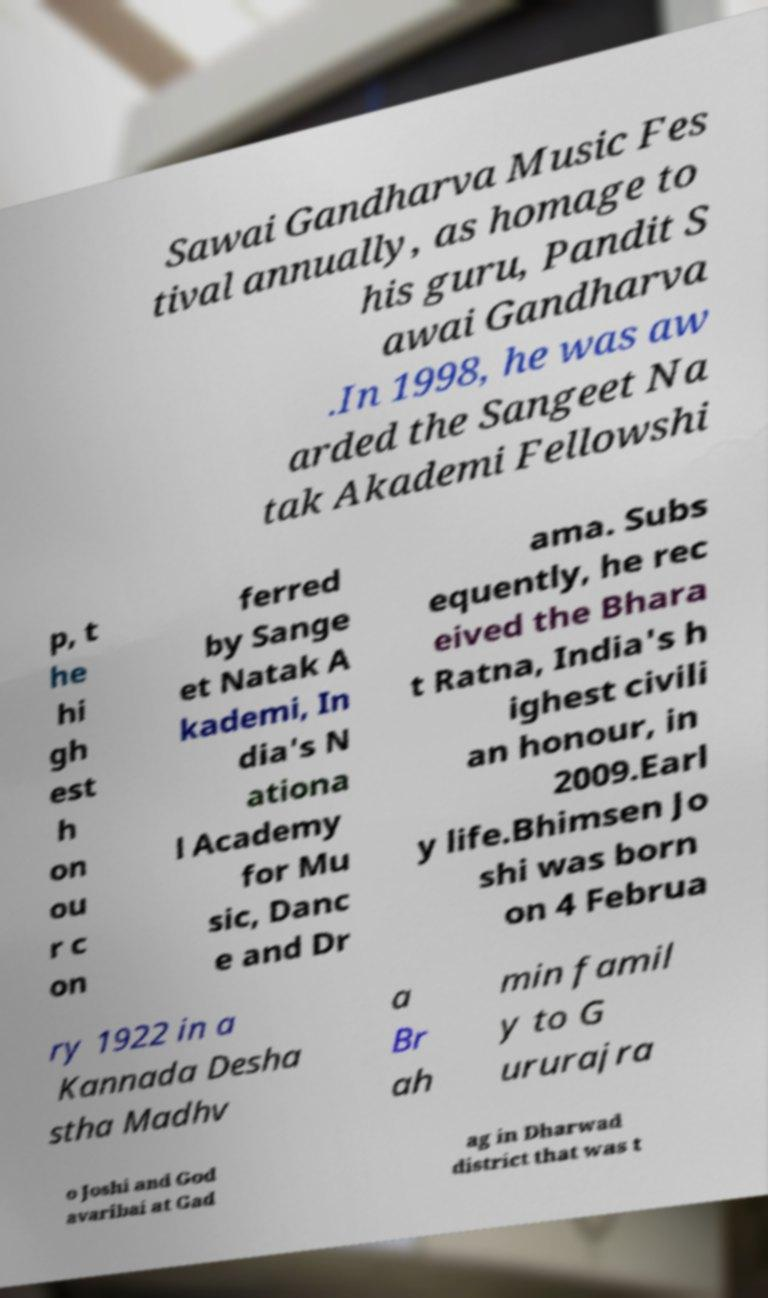I need the written content from this picture converted into text. Can you do that? Sawai Gandharva Music Fes tival annually, as homage to his guru, Pandit S awai Gandharva .In 1998, he was aw arded the Sangeet Na tak Akademi Fellowshi p, t he hi gh est h on ou r c on ferred by Sange et Natak A kademi, In dia's N ationa l Academy for Mu sic, Danc e and Dr ama. Subs equently, he rec eived the Bhara t Ratna, India's h ighest civili an honour, in 2009.Earl y life.Bhimsen Jo shi was born on 4 Februa ry 1922 in a Kannada Desha stha Madhv a Br ah min famil y to G ururajra o Joshi and God avaribai at Gad ag in Dharwad district that was t 